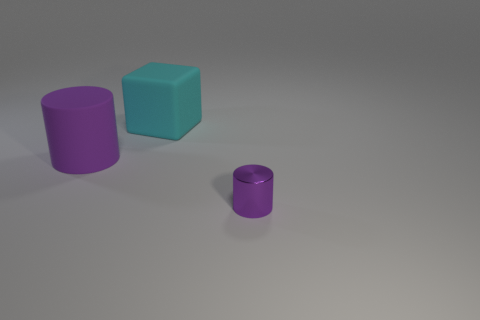Add 3 cyan rubber spheres. How many objects exist? 6 Subtract all blocks. How many objects are left? 2 Subtract all brown cylinders. Subtract all yellow balls. How many cylinders are left? 2 Subtract all brown cylinders. How many blue blocks are left? 0 Subtract all rubber things. Subtract all cyan matte blocks. How many objects are left? 0 Add 1 tiny things. How many tiny things are left? 2 Add 2 purple rubber cylinders. How many purple rubber cylinders exist? 3 Subtract 0 cyan balls. How many objects are left? 3 